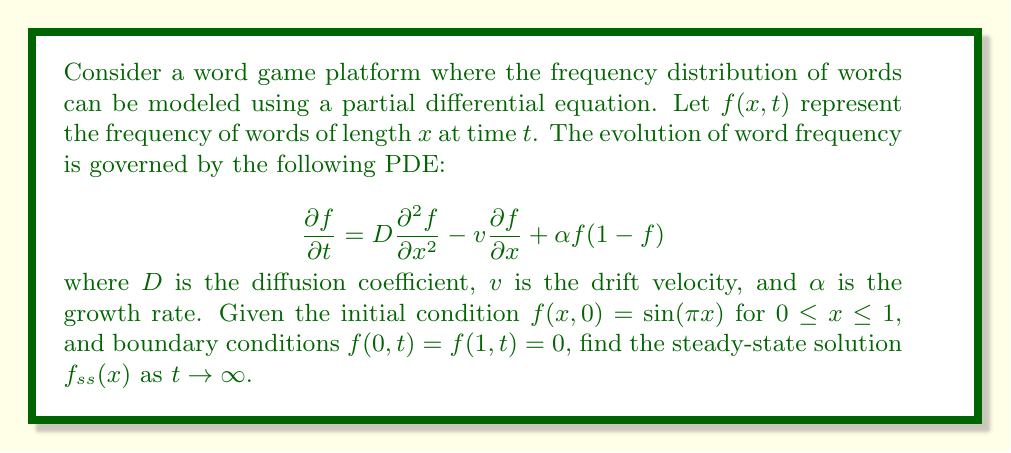What is the answer to this math problem? To solve this problem, we'll follow these steps:

1) First, we note that the steady-state solution is independent of time. So, we set $\frac{\partial f}{\partial t} = 0$ in the original PDE.

2) This gives us the steady-state equation:

   $$0 = D\frac{d^2 f_{ss}}{dx^2} - v\frac{df_{ss}}{dx} + \alpha f_{ss}(1-f_{ss})$$

3) This is a second-order nonlinear ODE. To simplify it, we can make the following substitutions:

   Let $y = f_{ss}$ and $y' = \frac{dy}{dx}$

4) The equation becomes:

   $$Dy'' - vy' + \alpha y(1-y) = 0$$

5) This is still a nonlinear equation and doesn't have a general analytical solution. However, given the boundary conditions $f(0,t) = f(1,t) = 0$, we can infer that the steady-state solution should also satisfy $y(0) = y(1) = 0$.

6) Given these boundary conditions and the initial condition $f(x,0) = \sin(\pi x)$, we can propose a solution of the form:

   $$y = A\sin(\pi x)$$

   where $A$ is a constant to be determined.

7) Substituting this into our steady-state equation:

   $$D(-A\pi^2\sin(\pi x)) - v(A\pi\cos(\pi x)) + \alpha A\sin(\pi x)(1-A\sin(\pi x)) = 0$$

8) For this to be true for all $x$, we must have:

   $$-DA\pi^2 + \alpha A - \alpha A^2 = 0$$

   (The term with $\cos(\pi x)$ vanishes due to the boundary conditions)

9) Solving this quadratic equation for $A$:

   $$A = 0$$ or $$A = 1 - \frac{D\pi^2}{\alpha}$$

10) The zero solution is trivial and doesn't match our initial condition. Therefore, the non-trivial steady-state solution is:

    $$f_{ss}(x) = (1 - \frac{D\pi^2}{\alpha})\sin(\pi x)$$

This solution is valid when $\alpha > D\pi^2$, ensuring that the amplitude is positive.
Answer: The steady-state solution is:

$$f_{ss}(x) = (1 - \frac{D\pi^2}{\alpha})\sin(\pi x)$$

where $\alpha > D\pi^2$ 